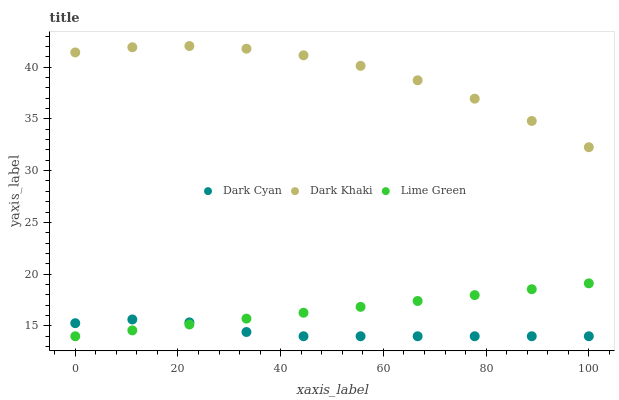Does Dark Cyan have the minimum area under the curve?
Answer yes or no. Yes. Does Dark Khaki have the maximum area under the curve?
Answer yes or no. Yes. Does Lime Green have the minimum area under the curve?
Answer yes or no. No. Does Lime Green have the maximum area under the curve?
Answer yes or no. No. Is Lime Green the smoothest?
Answer yes or no. Yes. Is Dark Khaki the roughest?
Answer yes or no. Yes. Is Dark Khaki the smoothest?
Answer yes or no. No. Is Lime Green the roughest?
Answer yes or no. No. Does Dark Cyan have the lowest value?
Answer yes or no. Yes. Does Dark Khaki have the lowest value?
Answer yes or no. No. Does Dark Khaki have the highest value?
Answer yes or no. Yes. Does Lime Green have the highest value?
Answer yes or no. No. Is Lime Green less than Dark Khaki?
Answer yes or no. Yes. Is Dark Khaki greater than Dark Cyan?
Answer yes or no. Yes. Does Lime Green intersect Dark Cyan?
Answer yes or no. Yes. Is Lime Green less than Dark Cyan?
Answer yes or no. No. Is Lime Green greater than Dark Cyan?
Answer yes or no. No. Does Lime Green intersect Dark Khaki?
Answer yes or no. No. 